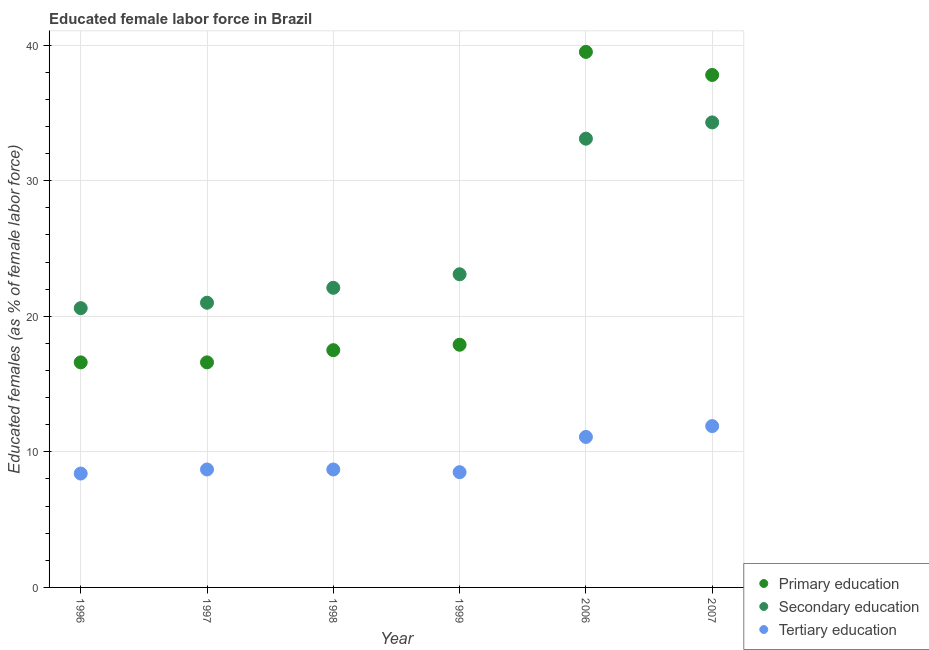How many different coloured dotlines are there?
Your response must be concise. 3. Is the number of dotlines equal to the number of legend labels?
Provide a short and direct response. Yes. What is the percentage of female labor force who received primary education in 1999?
Your answer should be compact. 17.9. Across all years, what is the maximum percentage of female labor force who received primary education?
Provide a succinct answer. 39.5. Across all years, what is the minimum percentage of female labor force who received secondary education?
Offer a terse response. 20.6. In which year was the percentage of female labor force who received secondary education maximum?
Provide a succinct answer. 2007. What is the total percentage of female labor force who received secondary education in the graph?
Offer a very short reply. 154.2. What is the difference between the percentage of female labor force who received secondary education in 1996 and that in 2007?
Ensure brevity in your answer.  -13.7. What is the difference between the percentage of female labor force who received tertiary education in 1997 and the percentage of female labor force who received secondary education in 2006?
Provide a short and direct response. -24.4. What is the average percentage of female labor force who received primary education per year?
Give a very brief answer. 24.32. In the year 1999, what is the difference between the percentage of female labor force who received primary education and percentage of female labor force who received tertiary education?
Make the answer very short. 9.4. In how many years, is the percentage of female labor force who received primary education greater than 20 %?
Make the answer very short. 2. What is the ratio of the percentage of female labor force who received tertiary education in 1996 to that in 2006?
Make the answer very short. 0.76. Is the percentage of female labor force who received tertiary education in 1997 less than that in 1998?
Provide a succinct answer. No. What is the difference between the highest and the second highest percentage of female labor force who received tertiary education?
Your response must be concise. 0.8. What is the difference between the highest and the lowest percentage of female labor force who received tertiary education?
Offer a terse response. 3.5. Is the sum of the percentage of female labor force who received primary education in 2006 and 2007 greater than the maximum percentage of female labor force who received tertiary education across all years?
Provide a succinct answer. Yes. Is it the case that in every year, the sum of the percentage of female labor force who received primary education and percentage of female labor force who received secondary education is greater than the percentage of female labor force who received tertiary education?
Keep it short and to the point. Yes. Is the percentage of female labor force who received primary education strictly less than the percentage of female labor force who received tertiary education over the years?
Ensure brevity in your answer.  No. Does the graph contain grids?
Provide a succinct answer. Yes. Where does the legend appear in the graph?
Ensure brevity in your answer.  Bottom right. How many legend labels are there?
Your answer should be compact. 3. How are the legend labels stacked?
Keep it short and to the point. Vertical. What is the title of the graph?
Provide a succinct answer. Educated female labor force in Brazil. Does "Total employers" appear as one of the legend labels in the graph?
Your response must be concise. No. What is the label or title of the X-axis?
Make the answer very short. Year. What is the label or title of the Y-axis?
Provide a succinct answer. Educated females (as % of female labor force). What is the Educated females (as % of female labor force) of Primary education in 1996?
Give a very brief answer. 16.6. What is the Educated females (as % of female labor force) in Secondary education in 1996?
Your response must be concise. 20.6. What is the Educated females (as % of female labor force) of Tertiary education in 1996?
Provide a succinct answer. 8.4. What is the Educated females (as % of female labor force) in Primary education in 1997?
Provide a succinct answer. 16.6. What is the Educated females (as % of female labor force) in Tertiary education in 1997?
Make the answer very short. 8.7. What is the Educated females (as % of female labor force) in Primary education in 1998?
Your answer should be compact. 17.5. What is the Educated females (as % of female labor force) of Secondary education in 1998?
Offer a very short reply. 22.1. What is the Educated females (as % of female labor force) of Tertiary education in 1998?
Make the answer very short. 8.7. What is the Educated females (as % of female labor force) of Primary education in 1999?
Provide a short and direct response. 17.9. What is the Educated females (as % of female labor force) in Secondary education in 1999?
Provide a succinct answer. 23.1. What is the Educated females (as % of female labor force) in Tertiary education in 1999?
Provide a succinct answer. 8.5. What is the Educated females (as % of female labor force) of Primary education in 2006?
Give a very brief answer. 39.5. What is the Educated females (as % of female labor force) in Secondary education in 2006?
Offer a very short reply. 33.1. What is the Educated females (as % of female labor force) of Tertiary education in 2006?
Your response must be concise. 11.1. What is the Educated females (as % of female labor force) in Primary education in 2007?
Ensure brevity in your answer.  37.8. What is the Educated females (as % of female labor force) in Secondary education in 2007?
Offer a very short reply. 34.3. What is the Educated females (as % of female labor force) of Tertiary education in 2007?
Offer a very short reply. 11.9. Across all years, what is the maximum Educated females (as % of female labor force) of Primary education?
Provide a succinct answer. 39.5. Across all years, what is the maximum Educated females (as % of female labor force) in Secondary education?
Your response must be concise. 34.3. Across all years, what is the maximum Educated females (as % of female labor force) in Tertiary education?
Make the answer very short. 11.9. Across all years, what is the minimum Educated females (as % of female labor force) of Primary education?
Keep it short and to the point. 16.6. Across all years, what is the minimum Educated females (as % of female labor force) in Secondary education?
Your answer should be very brief. 20.6. Across all years, what is the minimum Educated females (as % of female labor force) in Tertiary education?
Make the answer very short. 8.4. What is the total Educated females (as % of female labor force) of Primary education in the graph?
Offer a very short reply. 145.9. What is the total Educated females (as % of female labor force) in Secondary education in the graph?
Offer a very short reply. 154.2. What is the total Educated females (as % of female labor force) of Tertiary education in the graph?
Offer a very short reply. 57.3. What is the difference between the Educated females (as % of female labor force) in Primary education in 1996 and that in 1997?
Provide a succinct answer. 0. What is the difference between the Educated females (as % of female labor force) in Tertiary education in 1996 and that in 1997?
Give a very brief answer. -0.3. What is the difference between the Educated females (as % of female labor force) of Primary education in 1996 and that in 1998?
Give a very brief answer. -0.9. What is the difference between the Educated females (as % of female labor force) of Secondary education in 1996 and that in 1998?
Your answer should be compact. -1.5. What is the difference between the Educated females (as % of female labor force) of Tertiary education in 1996 and that in 1998?
Provide a short and direct response. -0.3. What is the difference between the Educated females (as % of female labor force) of Secondary education in 1996 and that in 1999?
Your response must be concise. -2.5. What is the difference between the Educated females (as % of female labor force) in Tertiary education in 1996 and that in 1999?
Provide a short and direct response. -0.1. What is the difference between the Educated females (as % of female labor force) in Primary education in 1996 and that in 2006?
Your response must be concise. -22.9. What is the difference between the Educated females (as % of female labor force) in Secondary education in 1996 and that in 2006?
Give a very brief answer. -12.5. What is the difference between the Educated females (as % of female labor force) in Tertiary education in 1996 and that in 2006?
Offer a very short reply. -2.7. What is the difference between the Educated females (as % of female labor force) in Primary education in 1996 and that in 2007?
Your answer should be compact. -21.2. What is the difference between the Educated females (as % of female labor force) of Secondary education in 1996 and that in 2007?
Provide a succinct answer. -13.7. What is the difference between the Educated females (as % of female labor force) of Tertiary education in 1996 and that in 2007?
Your response must be concise. -3.5. What is the difference between the Educated females (as % of female labor force) of Primary education in 1997 and that in 1998?
Offer a terse response. -0.9. What is the difference between the Educated females (as % of female labor force) of Secondary education in 1997 and that in 1998?
Provide a succinct answer. -1.1. What is the difference between the Educated females (as % of female labor force) in Tertiary education in 1997 and that in 1998?
Provide a short and direct response. 0. What is the difference between the Educated females (as % of female labor force) of Primary education in 1997 and that in 2006?
Give a very brief answer. -22.9. What is the difference between the Educated females (as % of female labor force) of Tertiary education in 1997 and that in 2006?
Offer a terse response. -2.4. What is the difference between the Educated females (as % of female labor force) in Primary education in 1997 and that in 2007?
Your answer should be compact. -21.2. What is the difference between the Educated females (as % of female labor force) in Secondary education in 1997 and that in 2007?
Ensure brevity in your answer.  -13.3. What is the difference between the Educated females (as % of female labor force) of Tertiary education in 1997 and that in 2007?
Make the answer very short. -3.2. What is the difference between the Educated females (as % of female labor force) in Primary education in 1998 and that in 1999?
Offer a very short reply. -0.4. What is the difference between the Educated females (as % of female labor force) of Primary education in 1998 and that in 2006?
Offer a terse response. -22. What is the difference between the Educated females (as % of female labor force) in Secondary education in 1998 and that in 2006?
Give a very brief answer. -11. What is the difference between the Educated females (as % of female labor force) of Primary education in 1998 and that in 2007?
Your answer should be compact. -20.3. What is the difference between the Educated females (as % of female labor force) of Tertiary education in 1998 and that in 2007?
Provide a short and direct response. -3.2. What is the difference between the Educated females (as % of female labor force) in Primary education in 1999 and that in 2006?
Keep it short and to the point. -21.6. What is the difference between the Educated females (as % of female labor force) of Primary education in 1999 and that in 2007?
Your answer should be very brief. -19.9. What is the difference between the Educated females (as % of female labor force) of Secondary education in 1999 and that in 2007?
Make the answer very short. -11.2. What is the difference between the Educated females (as % of female labor force) in Secondary education in 2006 and that in 2007?
Offer a very short reply. -1.2. What is the difference between the Educated females (as % of female labor force) in Primary education in 1996 and the Educated females (as % of female labor force) in Tertiary education in 1997?
Make the answer very short. 7.9. What is the difference between the Educated females (as % of female labor force) in Secondary education in 1996 and the Educated females (as % of female labor force) in Tertiary education in 1997?
Offer a very short reply. 11.9. What is the difference between the Educated females (as % of female labor force) in Primary education in 1996 and the Educated females (as % of female labor force) in Tertiary education in 1998?
Offer a very short reply. 7.9. What is the difference between the Educated females (as % of female labor force) in Primary education in 1996 and the Educated females (as % of female labor force) in Secondary education in 1999?
Your answer should be compact. -6.5. What is the difference between the Educated females (as % of female labor force) in Secondary education in 1996 and the Educated females (as % of female labor force) in Tertiary education in 1999?
Offer a terse response. 12.1. What is the difference between the Educated females (as % of female labor force) in Primary education in 1996 and the Educated females (as % of female labor force) in Secondary education in 2006?
Provide a short and direct response. -16.5. What is the difference between the Educated females (as % of female labor force) in Primary education in 1996 and the Educated females (as % of female labor force) in Secondary education in 2007?
Keep it short and to the point. -17.7. What is the difference between the Educated females (as % of female labor force) in Primary education in 1996 and the Educated females (as % of female labor force) in Tertiary education in 2007?
Ensure brevity in your answer.  4.7. What is the difference between the Educated females (as % of female labor force) of Primary education in 1997 and the Educated females (as % of female labor force) of Secondary education in 1999?
Give a very brief answer. -6.5. What is the difference between the Educated females (as % of female labor force) in Secondary education in 1997 and the Educated females (as % of female labor force) in Tertiary education in 1999?
Offer a terse response. 12.5. What is the difference between the Educated females (as % of female labor force) in Primary education in 1997 and the Educated females (as % of female labor force) in Secondary education in 2006?
Offer a very short reply. -16.5. What is the difference between the Educated females (as % of female labor force) of Primary education in 1997 and the Educated females (as % of female labor force) of Tertiary education in 2006?
Your response must be concise. 5.5. What is the difference between the Educated females (as % of female labor force) of Primary education in 1997 and the Educated females (as % of female labor force) of Secondary education in 2007?
Keep it short and to the point. -17.7. What is the difference between the Educated females (as % of female labor force) of Primary education in 1997 and the Educated females (as % of female labor force) of Tertiary education in 2007?
Provide a short and direct response. 4.7. What is the difference between the Educated females (as % of female labor force) in Primary education in 1998 and the Educated females (as % of female labor force) in Tertiary education in 1999?
Make the answer very short. 9. What is the difference between the Educated females (as % of female labor force) in Primary education in 1998 and the Educated females (as % of female labor force) in Secondary education in 2006?
Keep it short and to the point. -15.6. What is the difference between the Educated females (as % of female labor force) in Primary education in 1998 and the Educated females (as % of female labor force) in Tertiary education in 2006?
Provide a succinct answer. 6.4. What is the difference between the Educated females (as % of female labor force) of Secondary education in 1998 and the Educated females (as % of female labor force) of Tertiary education in 2006?
Offer a terse response. 11. What is the difference between the Educated females (as % of female labor force) in Primary education in 1998 and the Educated females (as % of female labor force) in Secondary education in 2007?
Your response must be concise. -16.8. What is the difference between the Educated females (as % of female labor force) of Primary education in 1999 and the Educated females (as % of female labor force) of Secondary education in 2006?
Offer a terse response. -15.2. What is the difference between the Educated females (as % of female labor force) of Primary education in 1999 and the Educated females (as % of female labor force) of Secondary education in 2007?
Offer a very short reply. -16.4. What is the difference between the Educated females (as % of female labor force) in Primary education in 2006 and the Educated females (as % of female labor force) in Tertiary education in 2007?
Your answer should be compact. 27.6. What is the difference between the Educated females (as % of female labor force) of Secondary education in 2006 and the Educated females (as % of female labor force) of Tertiary education in 2007?
Offer a very short reply. 21.2. What is the average Educated females (as % of female labor force) of Primary education per year?
Offer a very short reply. 24.32. What is the average Educated females (as % of female labor force) of Secondary education per year?
Provide a succinct answer. 25.7. What is the average Educated females (as % of female labor force) in Tertiary education per year?
Provide a short and direct response. 9.55. In the year 1996, what is the difference between the Educated females (as % of female labor force) of Primary education and Educated females (as % of female labor force) of Tertiary education?
Keep it short and to the point. 8.2. In the year 1996, what is the difference between the Educated females (as % of female labor force) of Secondary education and Educated females (as % of female labor force) of Tertiary education?
Provide a short and direct response. 12.2. In the year 1998, what is the difference between the Educated females (as % of female labor force) in Primary education and Educated females (as % of female labor force) in Secondary education?
Offer a very short reply. -4.6. In the year 1998, what is the difference between the Educated females (as % of female labor force) of Primary education and Educated females (as % of female labor force) of Tertiary education?
Provide a succinct answer. 8.8. In the year 1998, what is the difference between the Educated females (as % of female labor force) of Secondary education and Educated females (as % of female labor force) of Tertiary education?
Your response must be concise. 13.4. In the year 1999, what is the difference between the Educated females (as % of female labor force) in Primary education and Educated females (as % of female labor force) in Secondary education?
Provide a short and direct response. -5.2. In the year 1999, what is the difference between the Educated females (as % of female labor force) of Primary education and Educated females (as % of female labor force) of Tertiary education?
Make the answer very short. 9.4. In the year 1999, what is the difference between the Educated females (as % of female labor force) in Secondary education and Educated females (as % of female labor force) in Tertiary education?
Provide a succinct answer. 14.6. In the year 2006, what is the difference between the Educated females (as % of female labor force) of Primary education and Educated females (as % of female labor force) of Tertiary education?
Offer a very short reply. 28.4. In the year 2007, what is the difference between the Educated females (as % of female labor force) in Primary education and Educated females (as % of female labor force) in Tertiary education?
Make the answer very short. 25.9. In the year 2007, what is the difference between the Educated females (as % of female labor force) in Secondary education and Educated females (as % of female labor force) in Tertiary education?
Provide a succinct answer. 22.4. What is the ratio of the Educated females (as % of female labor force) in Primary education in 1996 to that in 1997?
Your answer should be very brief. 1. What is the ratio of the Educated females (as % of female labor force) in Tertiary education in 1996 to that in 1997?
Ensure brevity in your answer.  0.97. What is the ratio of the Educated females (as % of female labor force) in Primary education in 1996 to that in 1998?
Provide a succinct answer. 0.95. What is the ratio of the Educated females (as % of female labor force) in Secondary education in 1996 to that in 1998?
Your response must be concise. 0.93. What is the ratio of the Educated females (as % of female labor force) in Tertiary education in 1996 to that in 1998?
Provide a short and direct response. 0.97. What is the ratio of the Educated females (as % of female labor force) in Primary education in 1996 to that in 1999?
Your answer should be very brief. 0.93. What is the ratio of the Educated females (as % of female labor force) of Secondary education in 1996 to that in 1999?
Your answer should be very brief. 0.89. What is the ratio of the Educated females (as % of female labor force) of Primary education in 1996 to that in 2006?
Your answer should be very brief. 0.42. What is the ratio of the Educated females (as % of female labor force) in Secondary education in 1996 to that in 2006?
Offer a very short reply. 0.62. What is the ratio of the Educated females (as % of female labor force) of Tertiary education in 1996 to that in 2006?
Make the answer very short. 0.76. What is the ratio of the Educated females (as % of female labor force) of Primary education in 1996 to that in 2007?
Your answer should be compact. 0.44. What is the ratio of the Educated females (as % of female labor force) in Secondary education in 1996 to that in 2007?
Your answer should be compact. 0.6. What is the ratio of the Educated females (as % of female labor force) of Tertiary education in 1996 to that in 2007?
Your answer should be very brief. 0.71. What is the ratio of the Educated females (as % of female labor force) of Primary education in 1997 to that in 1998?
Your response must be concise. 0.95. What is the ratio of the Educated females (as % of female labor force) of Secondary education in 1997 to that in 1998?
Keep it short and to the point. 0.95. What is the ratio of the Educated females (as % of female labor force) of Tertiary education in 1997 to that in 1998?
Provide a succinct answer. 1. What is the ratio of the Educated females (as % of female labor force) of Primary education in 1997 to that in 1999?
Provide a succinct answer. 0.93. What is the ratio of the Educated females (as % of female labor force) in Tertiary education in 1997 to that in 1999?
Your answer should be compact. 1.02. What is the ratio of the Educated females (as % of female labor force) in Primary education in 1997 to that in 2006?
Give a very brief answer. 0.42. What is the ratio of the Educated females (as % of female labor force) of Secondary education in 1997 to that in 2006?
Give a very brief answer. 0.63. What is the ratio of the Educated females (as % of female labor force) in Tertiary education in 1997 to that in 2006?
Make the answer very short. 0.78. What is the ratio of the Educated females (as % of female labor force) of Primary education in 1997 to that in 2007?
Provide a succinct answer. 0.44. What is the ratio of the Educated females (as % of female labor force) of Secondary education in 1997 to that in 2007?
Offer a very short reply. 0.61. What is the ratio of the Educated females (as % of female labor force) of Tertiary education in 1997 to that in 2007?
Give a very brief answer. 0.73. What is the ratio of the Educated females (as % of female labor force) of Primary education in 1998 to that in 1999?
Give a very brief answer. 0.98. What is the ratio of the Educated females (as % of female labor force) of Secondary education in 1998 to that in 1999?
Your answer should be very brief. 0.96. What is the ratio of the Educated females (as % of female labor force) in Tertiary education in 1998 to that in 1999?
Offer a very short reply. 1.02. What is the ratio of the Educated females (as % of female labor force) of Primary education in 1998 to that in 2006?
Provide a short and direct response. 0.44. What is the ratio of the Educated females (as % of female labor force) of Secondary education in 1998 to that in 2006?
Offer a terse response. 0.67. What is the ratio of the Educated females (as % of female labor force) in Tertiary education in 1998 to that in 2006?
Make the answer very short. 0.78. What is the ratio of the Educated females (as % of female labor force) of Primary education in 1998 to that in 2007?
Keep it short and to the point. 0.46. What is the ratio of the Educated females (as % of female labor force) of Secondary education in 1998 to that in 2007?
Your answer should be very brief. 0.64. What is the ratio of the Educated females (as % of female labor force) in Tertiary education in 1998 to that in 2007?
Ensure brevity in your answer.  0.73. What is the ratio of the Educated females (as % of female labor force) of Primary education in 1999 to that in 2006?
Provide a succinct answer. 0.45. What is the ratio of the Educated females (as % of female labor force) in Secondary education in 1999 to that in 2006?
Your answer should be very brief. 0.7. What is the ratio of the Educated females (as % of female labor force) of Tertiary education in 1999 to that in 2006?
Ensure brevity in your answer.  0.77. What is the ratio of the Educated females (as % of female labor force) in Primary education in 1999 to that in 2007?
Offer a terse response. 0.47. What is the ratio of the Educated females (as % of female labor force) in Secondary education in 1999 to that in 2007?
Your response must be concise. 0.67. What is the ratio of the Educated females (as % of female labor force) in Tertiary education in 1999 to that in 2007?
Ensure brevity in your answer.  0.71. What is the ratio of the Educated females (as % of female labor force) in Primary education in 2006 to that in 2007?
Keep it short and to the point. 1.04. What is the ratio of the Educated females (as % of female labor force) of Tertiary education in 2006 to that in 2007?
Give a very brief answer. 0.93. What is the difference between the highest and the second highest Educated females (as % of female labor force) of Secondary education?
Provide a succinct answer. 1.2. What is the difference between the highest and the second highest Educated females (as % of female labor force) in Tertiary education?
Provide a short and direct response. 0.8. What is the difference between the highest and the lowest Educated females (as % of female labor force) of Primary education?
Your answer should be very brief. 22.9. What is the difference between the highest and the lowest Educated females (as % of female labor force) of Secondary education?
Give a very brief answer. 13.7. What is the difference between the highest and the lowest Educated females (as % of female labor force) in Tertiary education?
Offer a very short reply. 3.5. 